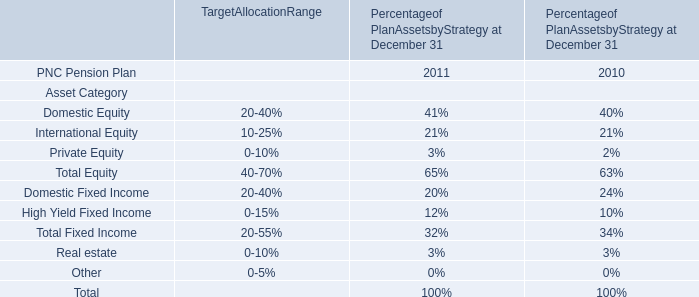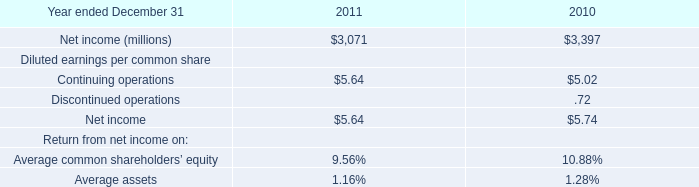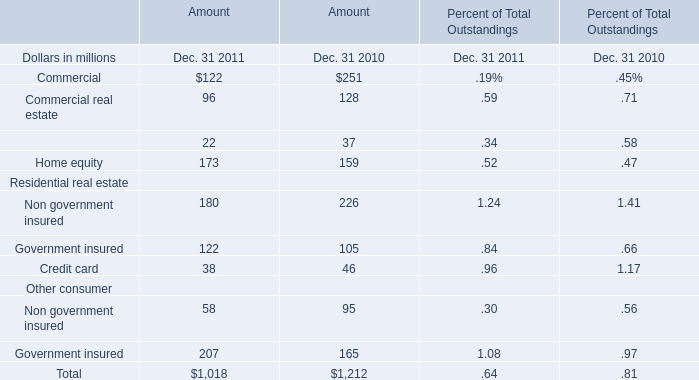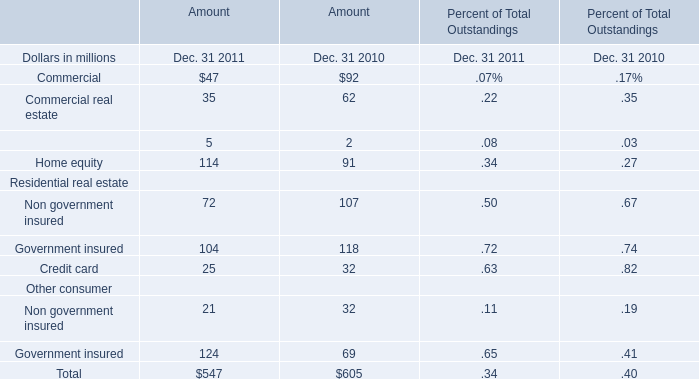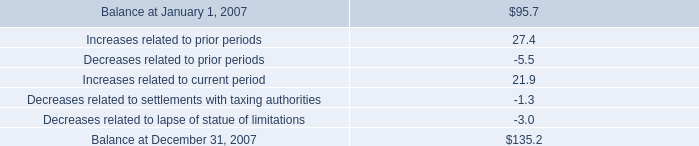How many elements' value in 2011 are lower than the previous year (for amount)? 
Answer: 6:commercial,Commercial real estate,Non government insured,Government insured,Credit card,Non government insured. 